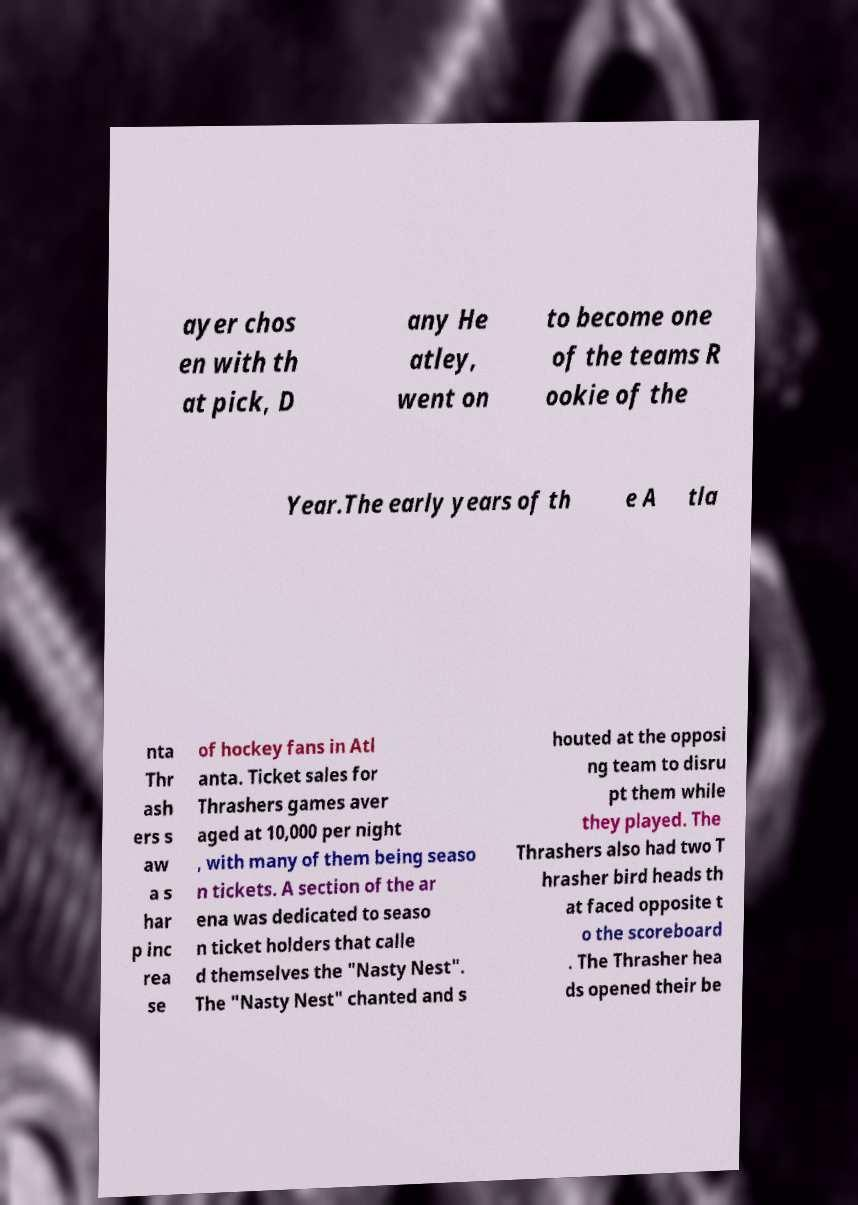For documentation purposes, I need the text within this image transcribed. Could you provide that? ayer chos en with th at pick, D any He atley, went on to become one of the teams R ookie of the Year.The early years of th e A tla nta Thr ash ers s aw a s har p inc rea se of hockey fans in Atl anta. Ticket sales for Thrashers games aver aged at 10,000 per night , with many of them being seaso n tickets. A section of the ar ena was dedicated to seaso n ticket holders that calle d themselves the "Nasty Nest". The "Nasty Nest" chanted and s houted at the opposi ng team to disru pt them while they played. The Thrashers also had two T hrasher bird heads th at faced opposite t o the scoreboard . The Thrasher hea ds opened their be 